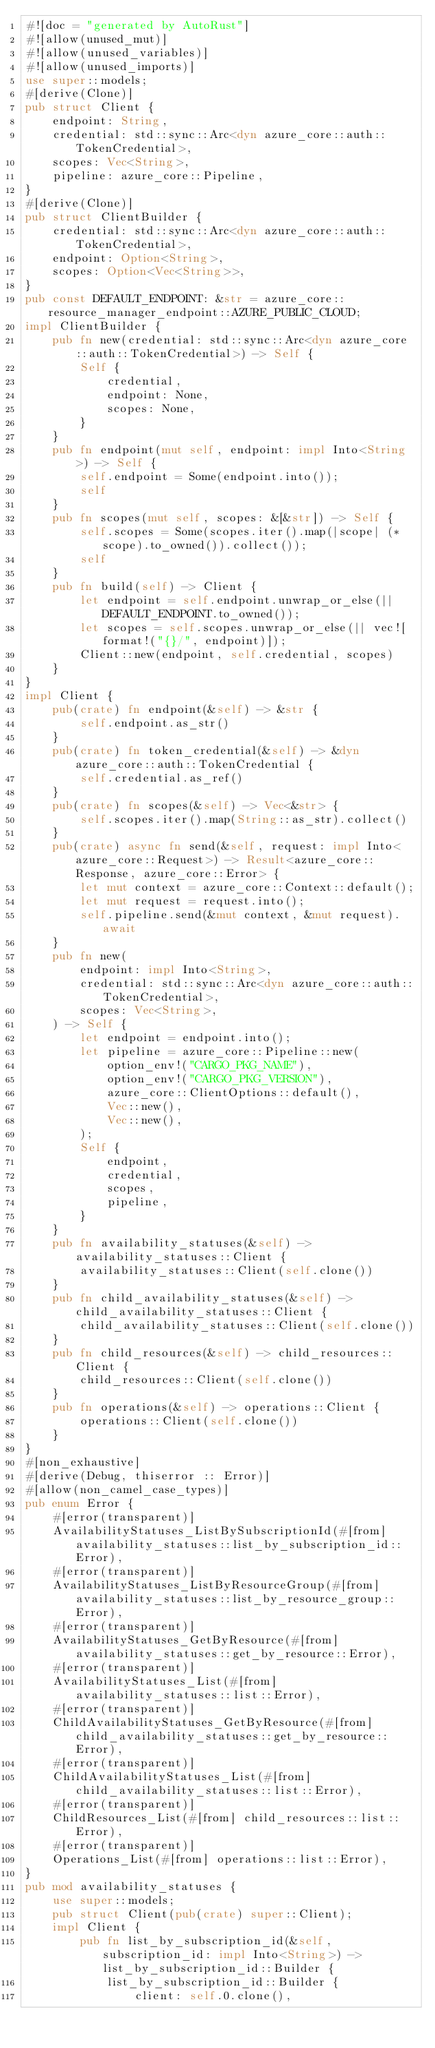Convert code to text. <code><loc_0><loc_0><loc_500><loc_500><_Rust_>#![doc = "generated by AutoRust"]
#![allow(unused_mut)]
#![allow(unused_variables)]
#![allow(unused_imports)]
use super::models;
#[derive(Clone)]
pub struct Client {
    endpoint: String,
    credential: std::sync::Arc<dyn azure_core::auth::TokenCredential>,
    scopes: Vec<String>,
    pipeline: azure_core::Pipeline,
}
#[derive(Clone)]
pub struct ClientBuilder {
    credential: std::sync::Arc<dyn azure_core::auth::TokenCredential>,
    endpoint: Option<String>,
    scopes: Option<Vec<String>>,
}
pub const DEFAULT_ENDPOINT: &str = azure_core::resource_manager_endpoint::AZURE_PUBLIC_CLOUD;
impl ClientBuilder {
    pub fn new(credential: std::sync::Arc<dyn azure_core::auth::TokenCredential>) -> Self {
        Self {
            credential,
            endpoint: None,
            scopes: None,
        }
    }
    pub fn endpoint(mut self, endpoint: impl Into<String>) -> Self {
        self.endpoint = Some(endpoint.into());
        self
    }
    pub fn scopes(mut self, scopes: &[&str]) -> Self {
        self.scopes = Some(scopes.iter().map(|scope| (*scope).to_owned()).collect());
        self
    }
    pub fn build(self) -> Client {
        let endpoint = self.endpoint.unwrap_or_else(|| DEFAULT_ENDPOINT.to_owned());
        let scopes = self.scopes.unwrap_or_else(|| vec![format!("{}/", endpoint)]);
        Client::new(endpoint, self.credential, scopes)
    }
}
impl Client {
    pub(crate) fn endpoint(&self) -> &str {
        self.endpoint.as_str()
    }
    pub(crate) fn token_credential(&self) -> &dyn azure_core::auth::TokenCredential {
        self.credential.as_ref()
    }
    pub(crate) fn scopes(&self) -> Vec<&str> {
        self.scopes.iter().map(String::as_str).collect()
    }
    pub(crate) async fn send(&self, request: impl Into<azure_core::Request>) -> Result<azure_core::Response, azure_core::Error> {
        let mut context = azure_core::Context::default();
        let mut request = request.into();
        self.pipeline.send(&mut context, &mut request).await
    }
    pub fn new(
        endpoint: impl Into<String>,
        credential: std::sync::Arc<dyn azure_core::auth::TokenCredential>,
        scopes: Vec<String>,
    ) -> Self {
        let endpoint = endpoint.into();
        let pipeline = azure_core::Pipeline::new(
            option_env!("CARGO_PKG_NAME"),
            option_env!("CARGO_PKG_VERSION"),
            azure_core::ClientOptions::default(),
            Vec::new(),
            Vec::new(),
        );
        Self {
            endpoint,
            credential,
            scopes,
            pipeline,
        }
    }
    pub fn availability_statuses(&self) -> availability_statuses::Client {
        availability_statuses::Client(self.clone())
    }
    pub fn child_availability_statuses(&self) -> child_availability_statuses::Client {
        child_availability_statuses::Client(self.clone())
    }
    pub fn child_resources(&self) -> child_resources::Client {
        child_resources::Client(self.clone())
    }
    pub fn operations(&self) -> operations::Client {
        operations::Client(self.clone())
    }
}
#[non_exhaustive]
#[derive(Debug, thiserror :: Error)]
#[allow(non_camel_case_types)]
pub enum Error {
    #[error(transparent)]
    AvailabilityStatuses_ListBySubscriptionId(#[from] availability_statuses::list_by_subscription_id::Error),
    #[error(transparent)]
    AvailabilityStatuses_ListByResourceGroup(#[from] availability_statuses::list_by_resource_group::Error),
    #[error(transparent)]
    AvailabilityStatuses_GetByResource(#[from] availability_statuses::get_by_resource::Error),
    #[error(transparent)]
    AvailabilityStatuses_List(#[from] availability_statuses::list::Error),
    #[error(transparent)]
    ChildAvailabilityStatuses_GetByResource(#[from] child_availability_statuses::get_by_resource::Error),
    #[error(transparent)]
    ChildAvailabilityStatuses_List(#[from] child_availability_statuses::list::Error),
    #[error(transparent)]
    ChildResources_List(#[from] child_resources::list::Error),
    #[error(transparent)]
    Operations_List(#[from] operations::list::Error),
}
pub mod availability_statuses {
    use super::models;
    pub struct Client(pub(crate) super::Client);
    impl Client {
        pub fn list_by_subscription_id(&self, subscription_id: impl Into<String>) -> list_by_subscription_id::Builder {
            list_by_subscription_id::Builder {
                client: self.0.clone(),</code> 